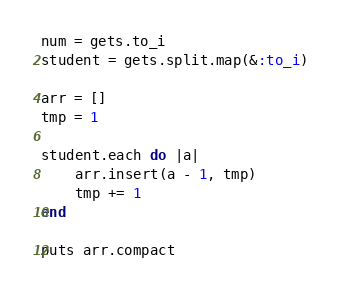Convert code to text. <code><loc_0><loc_0><loc_500><loc_500><_Ruby_>num = gets.to_i
student = gets.split.map(&:to_i)
 
arr = []
tmp = 1
 
student.each do |a|
    arr.insert(a - 1, tmp)
    tmp += 1
end
 
puts arr.compact</code> 